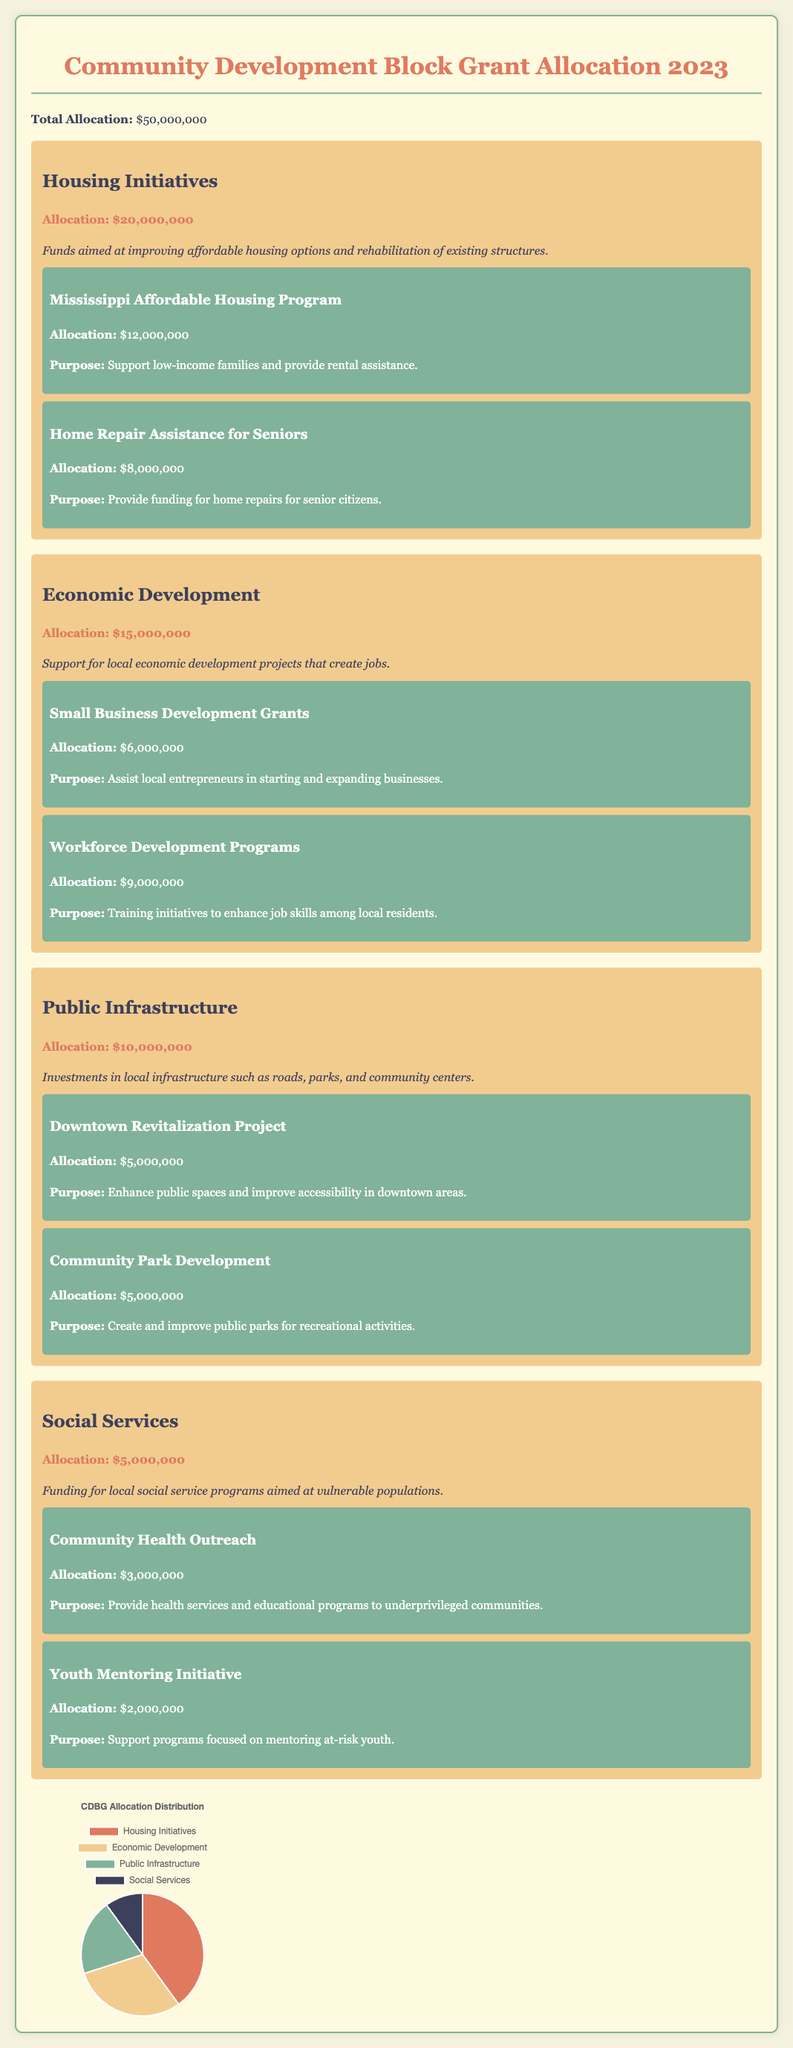What is the total allocation for CDBG in 2023? The total allocation is explicitly stated at the beginning of the document as $50,000,000.
Answer: $50,000,000 How much funding is dedicated to Housing Initiatives? The document specifies the allocation for Housing Initiatives as $20,000,000.
Answer: $20,000,000 What program receives the most funding under Housing Initiatives? The document lists the Mississippi Affordable Housing Program as having the highest allocation of $12,000,000 under Housing Initiatives.
Answer: Mississippi Affordable Housing Program What is the purpose of the Workforce Development Programs? The purpose of the Workforce Development Programs is described as training initiatives to enhance job skills among local residents.
Answer: Training initiatives to enhance job skills among local residents What is the combined allocation for Public Infrastructure and Social Services? The combined allocations are $10,000,000 for Public Infrastructure and $5,000,000 for Social Services, totaling $15,000,000.
Answer: $15,000,000 How many programs are listed under Economic Development? The document outlines two programs under Economic Development: Small Business Development Grants and Workforce Development Programs.
Answer: Two programs What funding is allocated for Youth Mentoring Initiative? The allocation for the Youth Mentoring Initiative is specifically stated as $2,000,000.
Answer: $2,000,000 What percentage of the total allocation is devoted to Economic Development? Economic Development receives $15,000,000 out of the total $50,000,000, which is 30%.
Answer: 30% 